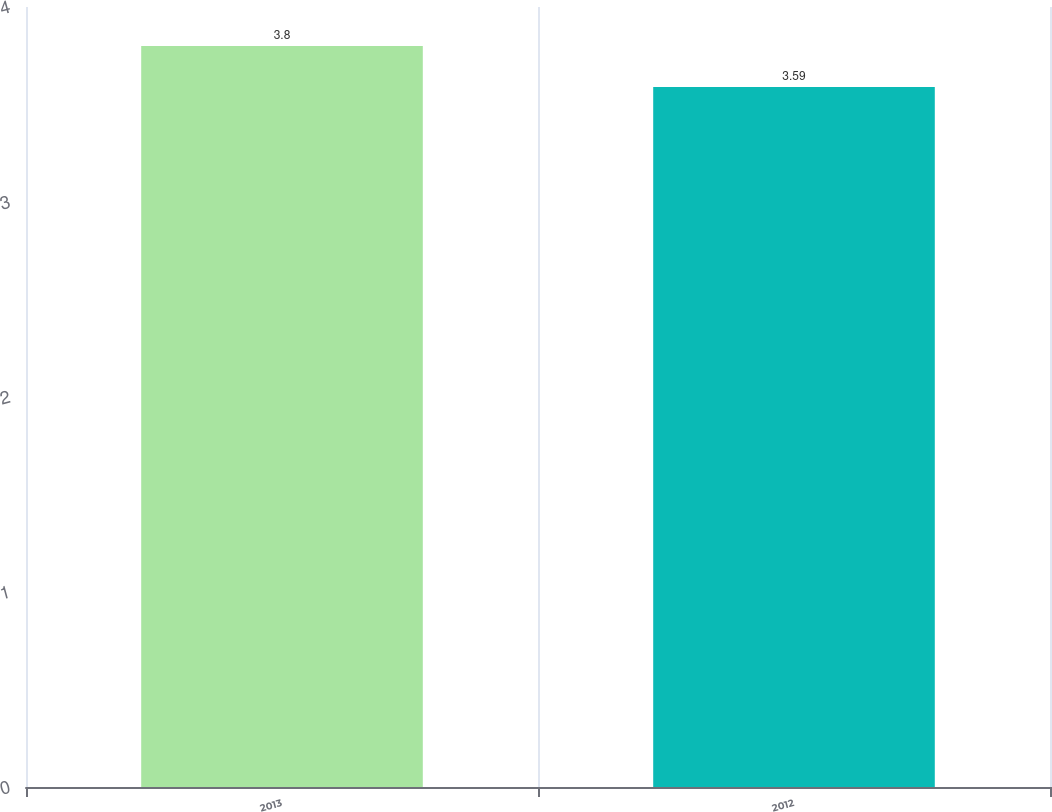Convert chart. <chart><loc_0><loc_0><loc_500><loc_500><bar_chart><fcel>2013<fcel>2012<nl><fcel>3.8<fcel>3.59<nl></chart> 